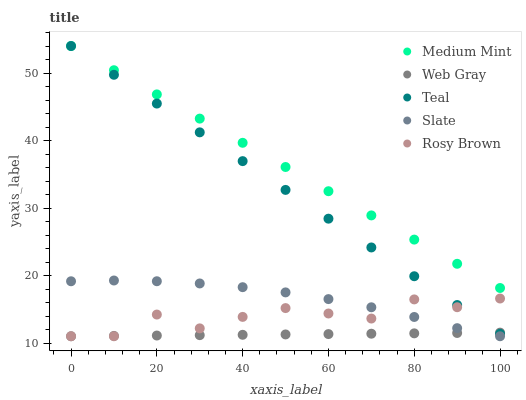Does Web Gray have the minimum area under the curve?
Answer yes or no. Yes. Does Medium Mint have the maximum area under the curve?
Answer yes or no. Yes. Does Slate have the minimum area under the curve?
Answer yes or no. No. Does Slate have the maximum area under the curve?
Answer yes or no. No. Is Teal the smoothest?
Answer yes or no. Yes. Is Rosy Brown the roughest?
Answer yes or no. Yes. Is Slate the smoothest?
Answer yes or no. No. Is Slate the roughest?
Answer yes or no. No. Does Slate have the lowest value?
Answer yes or no. Yes. Does Teal have the lowest value?
Answer yes or no. No. Does Teal have the highest value?
Answer yes or no. Yes. Does Slate have the highest value?
Answer yes or no. No. Is Slate less than Teal?
Answer yes or no. Yes. Is Teal greater than Slate?
Answer yes or no. Yes. Does Rosy Brown intersect Slate?
Answer yes or no. Yes. Is Rosy Brown less than Slate?
Answer yes or no. No. Is Rosy Brown greater than Slate?
Answer yes or no. No. Does Slate intersect Teal?
Answer yes or no. No. 